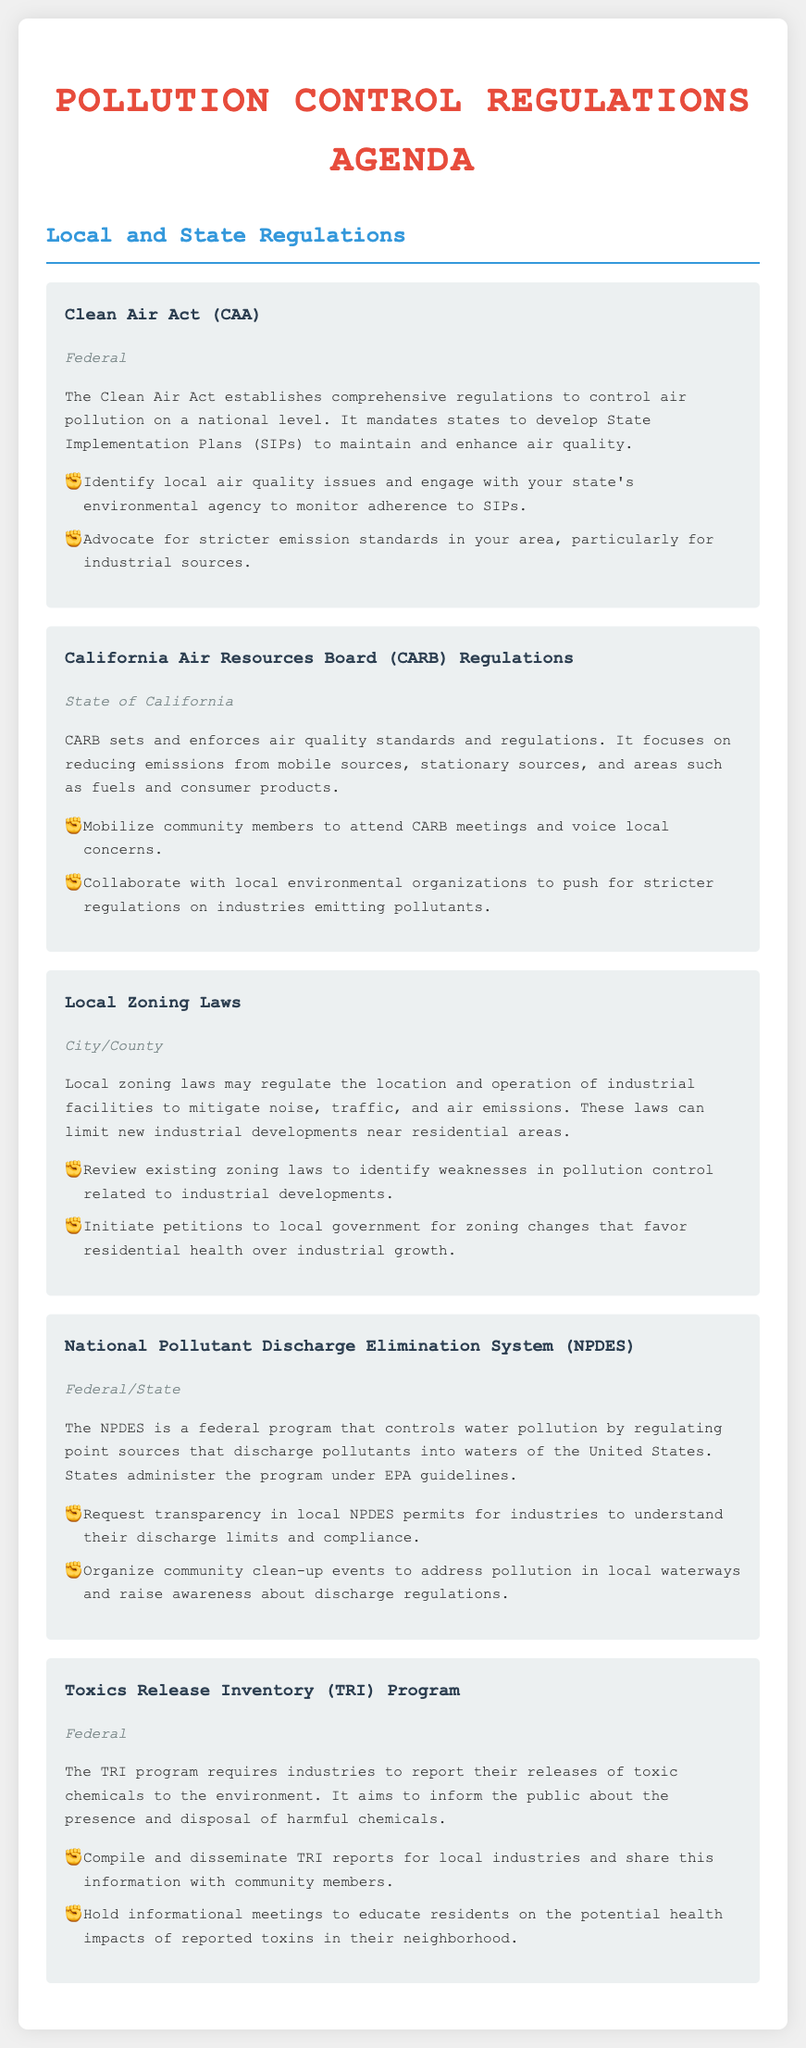What is the title of the document? The title is prominently displayed and indicates the focus of the document.
Answer: Pollution Control Regulations Agenda What federal program controls water pollution? The program is specifically mentioned in the document as regulating water pollution by point sources.
Answer: National Pollutant Discharge Elimination System Which state has specific air quality regulations enforced by CARB? The document identifies the jurisdiction where CARB operates.
Answer: State of California What action should community members take regarding CARB meetings? The actionable item outlines a specific community engagement strategy.
Answer: Mobilize community members to attend CARB meetings and voice local concerns What is the main goal of the Toxics Release Inventory Program? The purpose of the program is explained in terms of public information and safety.
Answer: Inform the public about the presence and disposal of harmful chemicals What local laws can mitigate industrial pollution impacts? The document specifies the type of laws that can help control pollution at a local level.
Answer: Local Zoning Laws What should communities do to understand NPDES permits? The actionable item focuses on a specific request related to local transparency and regulations.
Answer: Request transparency in local NPDES permits for industries to understand their discharge limits and compliance 